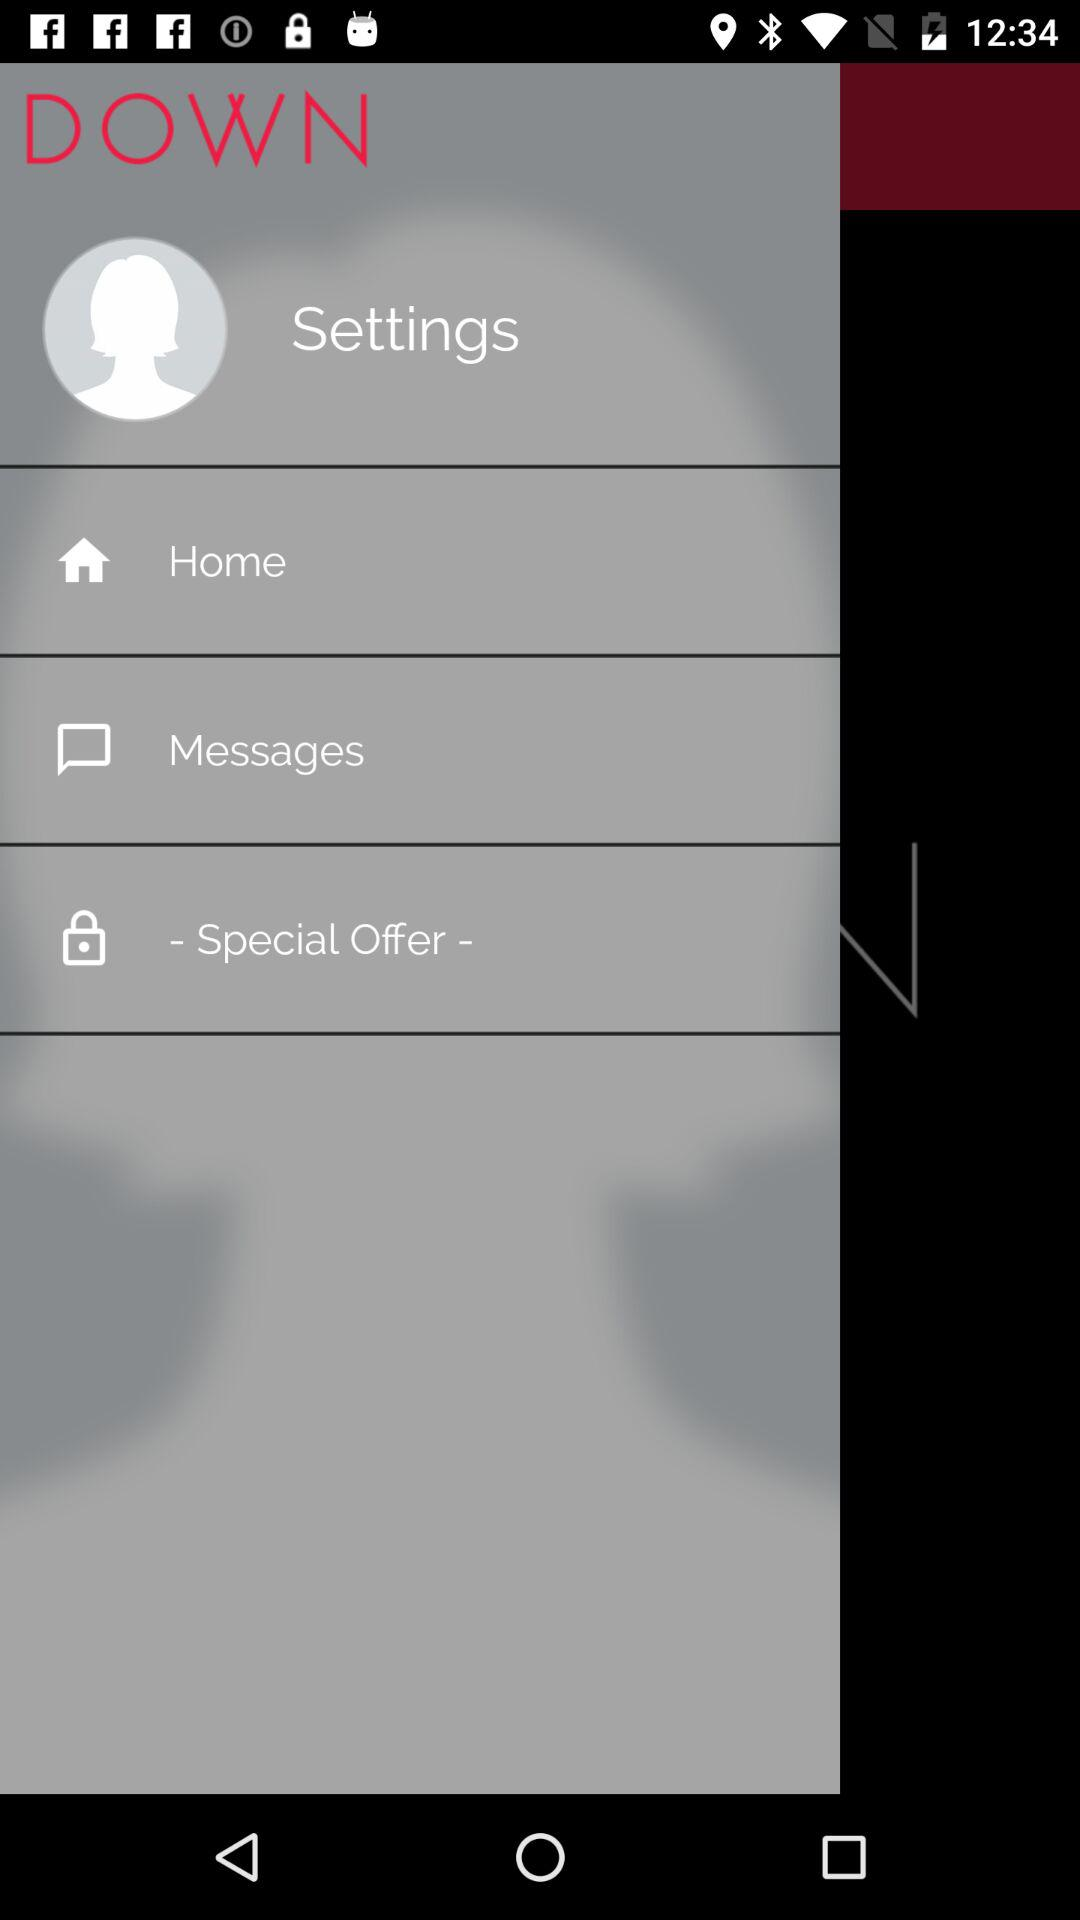What is the app name? The app name is "DOWN". 